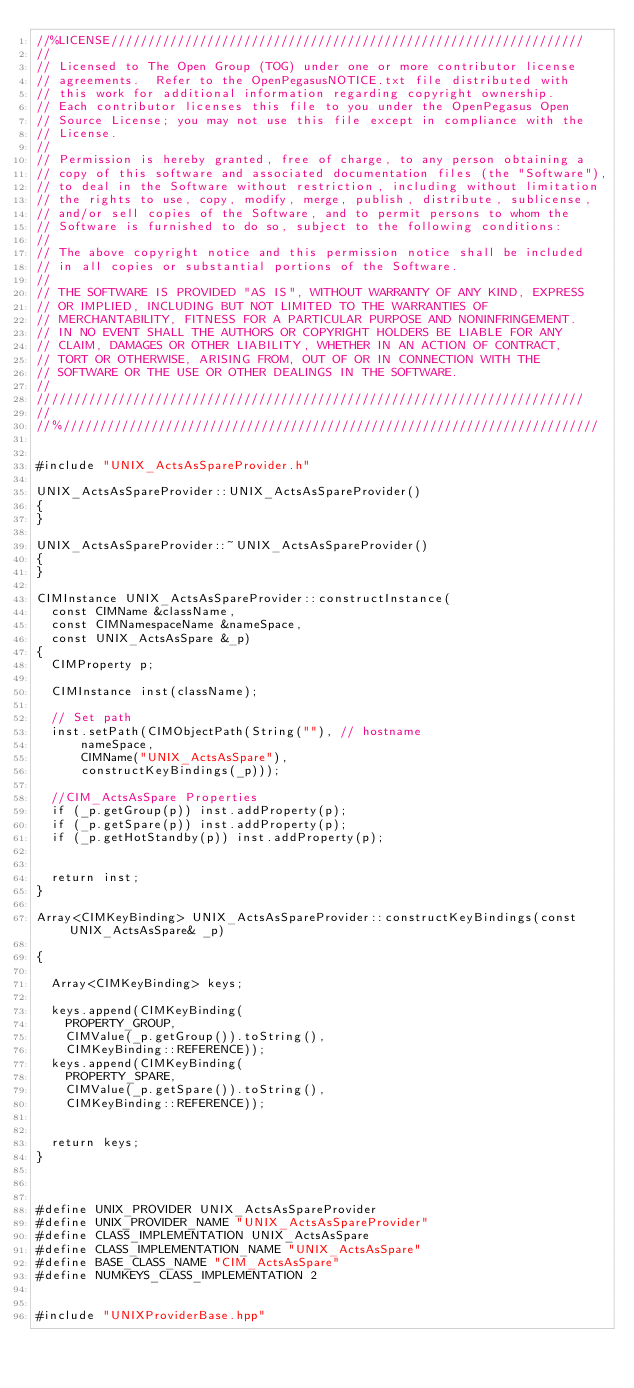<code> <loc_0><loc_0><loc_500><loc_500><_C++_>//%LICENSE////////////////////////////////////////////////////////////////
//
// Licensed to The Open Group (TOG) under one or more contributor license
// agreements.  Refer to the OpenPegasusNOTICE.txt file distributed with
// this work for additional information regarding copyright ownership.
// Each contributor licenses this file to you under the OpenPegasus Open
// Source License; you may not use this file except in compliance with the
// License.
//
// Permission is hereby granted, free of charge, to any person obtaining a
// copy of this software and associated documentation files (the "Software"),
// to deal in the Software without restriction, including without limitation
// the rights to use, copy, modify, merge, publish, distribute, sublicense,
// and/or sell copies of the Software, and to permit persons to whom the
// Software is furnished to do so, subject to the following conditions:
//
// The above copyright notice and this permission notice shall be included
// in all copies or substantial portions of the Software.
//
// THE SOFTWARE IS PROVIDED "AS IS", WITHOUT WARRANTY OF ANY KIND, EXPRESS
// OR IMPLIED, INCLUDING BUT NOT LIMITED TO THE WARRANTIES OF
// MERCHANTABILITY, FITNESS FOR A PARTICULAR PURPOSE AND NONINFRINGEMENT.
// IN NO EVENT SHALL THE AUTHORS OR COPYRIGHT HOLDERS BE LIABLE FOR ANY
// CLAIM, DAMAGES OR OTHER LIABILITY, WHETHER IN AN ACTION OF CONTRACT,
// TORT OR OTHERWISE, ARISING FROM, OUT OF OR IN CONNECTION WITH THE
// SOFTWARE OR THE USE OR OTHER DEALINGS IN THE SOFTWARE.
//
//////////////////////////////////////////////////////////////////////////
//
//%/////////////////////////////////////////////////////////////////////////


#include "UNIX_ActsAsSpareProvider.h"

UNIX_ActsAsSpareProvider::UNIX_ActsAsSpareProvider()
{
}

UNIX_ActsAsSpareProvider::~UNIX_ActsAsSpareProvider()
{
}

CIMInstance UNIX_ActsAsSpareProvider::constructInstance(
	const CIMName &className,
	const CIMNamespaceName &nameSpace,
	const UNIX_ActsAsSpare &_p)
{
	CIMProperty p;

	CIMInstance inst(className);

	// Set path
	inst.setPath(CIMObjectPath(String(""), // hostname
			nameSpace,
			CIMName("UNIX_ActsAsSpare"),
			constructKeyBindings(_p)));

	//CIM_ActsAsSpare Properties
	if (_p.getGroup(p)) inst.addProperty(p);
	if (_p.getSpare(p)) inst.addProperty(p);
	if (_p.getHotStandby(p)) inst.addProperty(p);


	return inst;
}

Array<CIMKeyBinding> UNIX_ActsAsSpareProvider::constructKeyBindings(const UNIX_ActsAsSpare& _p)

{

	Array<CIMKeyBinding> keys;

	keys.append(CIMKeyBinding(
		PROPERTY_GROUP,
		CIMValue(_p.getGroup()).toString(),
		CIMKeyBinding::REFERENCE));
	keys.append(CIMKeyBinding(
		PROPERTY_SPARE,
		CIMValue(_p.getSpare()).toString(),
		CIMKeyBinding::REFERENCE));


	return keys;
}



#define UNIX_PROVIDER UNIX_ActsAsSpareProvider
#define UNIX_PROVIDER_NAME "UNIX_ActsAsSpareProvider"
#define CLASS_IMPLEMENTATION UNIX_ActsAsSpare
#define CLASS_IMPLEMENTATION_NAME "UNIX_ActsAsSpare"
#define BASE_CLASS_NAME "CIM_ActsAsSpare"
#define NUMKEYS_CLASS_IMPLEMENTATION 2


#include "UNIXProviderBase.hpp"

</code> 